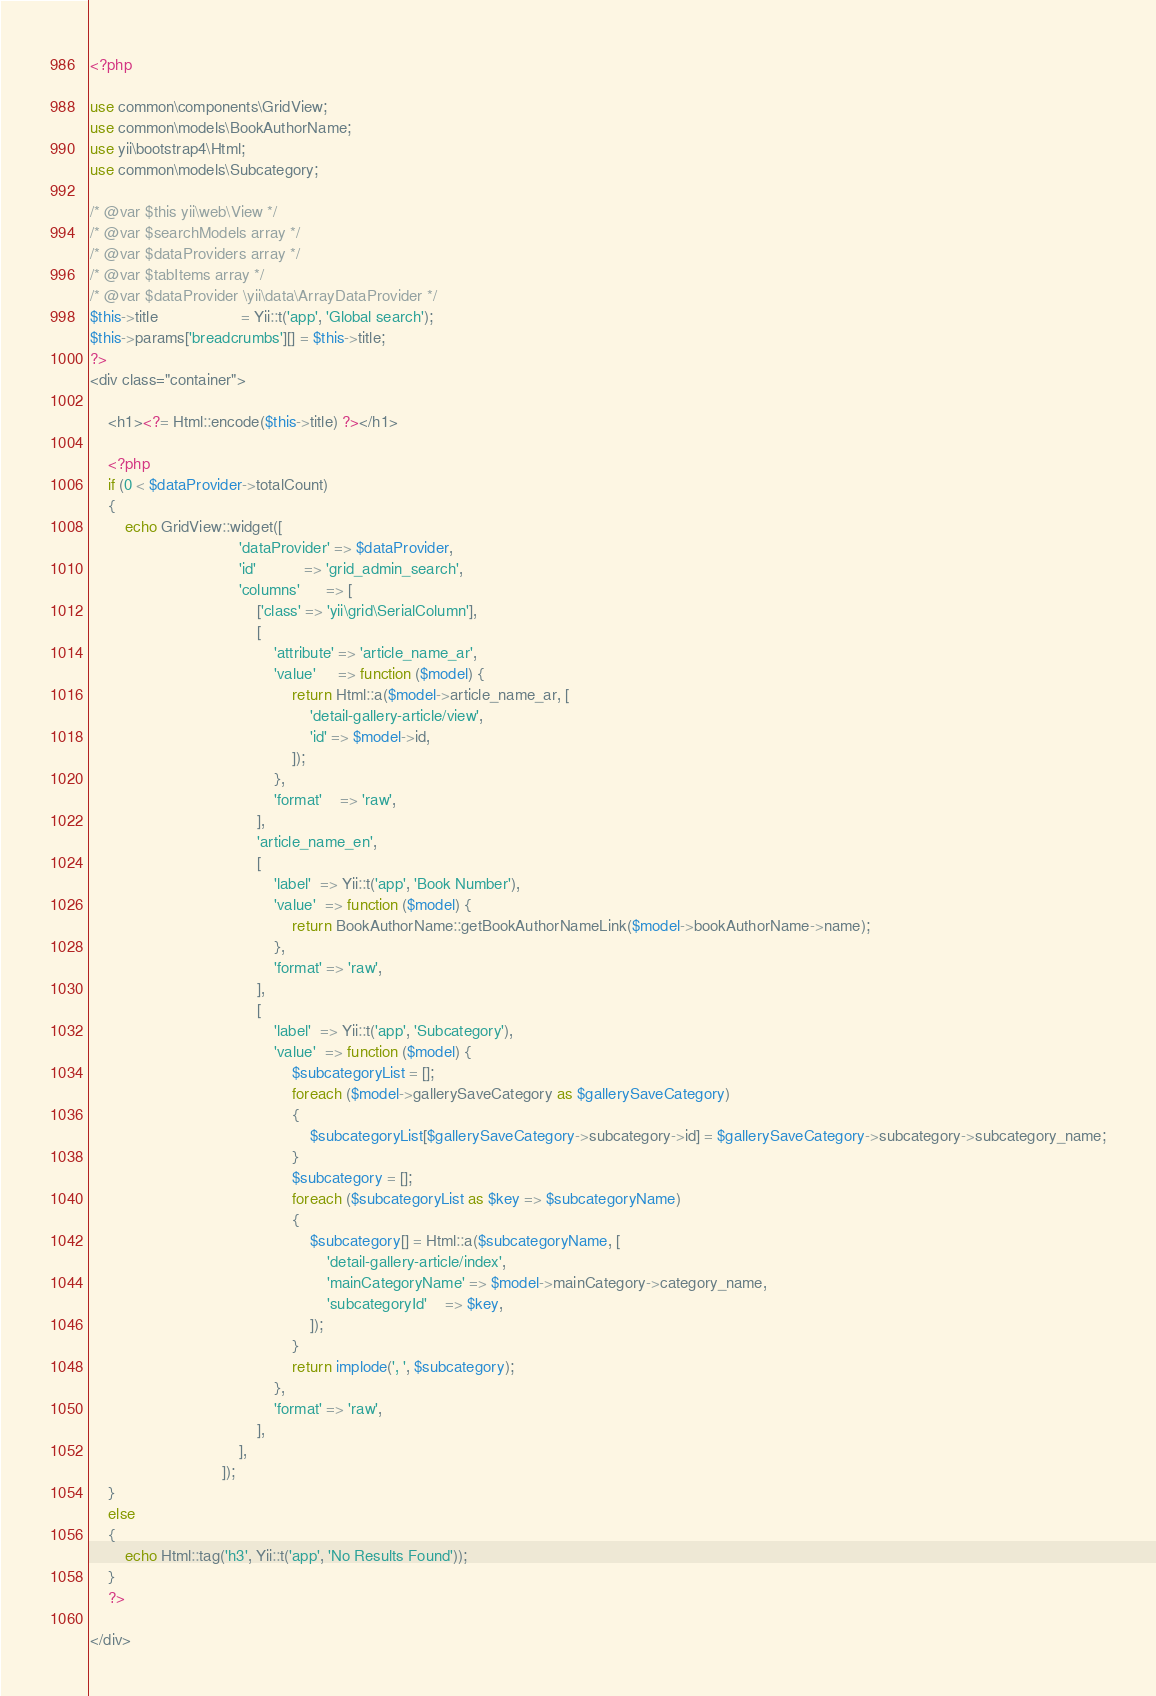Convert code to text. <code><loc_0><loc_0><loc_500><loc_500><_PHP_><?php

use common\components\GridView;
use common\models\BookAuthorName;
use yii\bootstrap4\Html;
use common\models\Subcategory;

/* @var $this yii\web\View */
/* @var $searchModels array */
/* @var $dataProviders array */
/* @var $tabItems array */
/* @var $dataProvider \yii\data\ArrayDataProvider */
$this->title                   = Yii::t('app', 'Global search');
$this->params['breadcrumbs'][] = $this->title;
?>
<div class="container">

    <h1><?= Html::encode($this->title) ?></h1>

    <?php
    if (0 < $dataProvider->totalCount)
    {
        echo GridView::widget([
                                  'dataProvider' => $dataProvider,
                                  'id'           => 'grid_admin_search',
                                  'columns'      => [
                                      ['class' => 'yii\grid\SerialColumn'],
                                      [
                                          'attribute' => 'article_name_ar',
                                          'value'     => function ($model) {
                                              return Html::a($model->article_name_ar, [
                                                  'detail-gallery-article/view',
                                                  'id' => $model->id,
                                              ]);
                                          },
                                          'format'    => 'raw',
                                      ],
                                      'article_name_en',
                                      [
                                          'label'  => Yii::t('app', 'Book Number'),
                                          'value'  => function ($model) {
                                              return BookAuthorName::getBookAuthorNameLink($model->bookAuthorName->name);
                                          },
                                          'format' => 'raw',
                                      ],
                                      [
                                          'label'  => Yii::t('app', 'Subcategory'),
                                          'value'  => function ($model) {
                                              $subcategoryList = [];
                                              foreach ($model->gallerySaveCategory as $gallerySaveCategory)
                                              {
                                                  $subcategoryList[$gallerySaveCategory->subcategory->id] = $gallerySaveCategory->subcategory->subcategory_name;
                                              }
                                              $subcategory = [];
                                              foreach ($subcategoryList as $key => $subcategoryName)
                                              {
                                                  $subcategory[] = Html::a($subcategoryName, [
                                                      'detail-gallery-article/index',
                                                      'mainCategoryName' => $model->mainCategory->category_name,
                                                      'subcategoryId'    => $key,
                                                  ]);
                                              }
                                              return implode(', ', $subcategory);
                                          },
                                          'format' => 'raw',
                                      ],
                                  ],
                              ]);
    }
    else
    {
        echo Html::tag('h3', Yii::t('app', 'No Results Found'));
    }
    ?>

</div>
</code> 